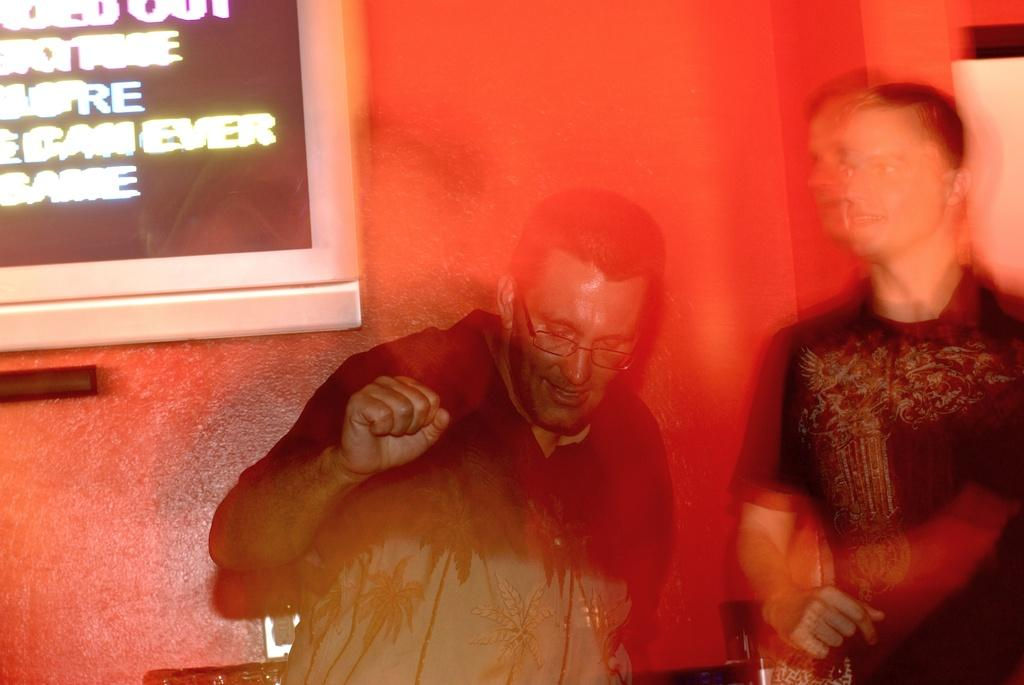How many people are in the image? There are two people in the image. Can you describe one of the people in the image? One of the people is a man, and he is wearing spectacles. What is the man doing in the image? The man is looking downwards. What color is the wall in the image? There is a red wall in the image. What is on the red wall? There is a screen on the red wall. What type of tools is the carpenter using in the image? There is no carpenter present in the image, nor are there any tools visible. What type of army equipment can be seen in the image? There is no army equipment present in the image. 